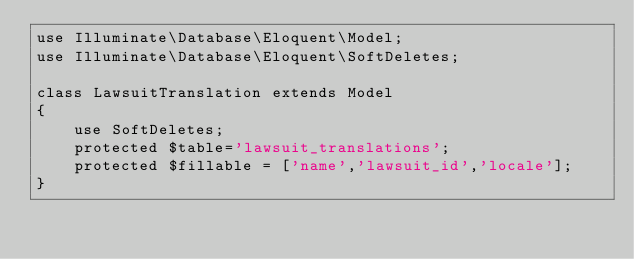Convert code to text. <code><loc_0><loc_0><loc_500><loc_500><_PHP_>use Illuminate\Database\Eloquent\Model;
use Illuminate\Database\Eloquent\SoftDeletes;

class LawsuitTranslation extends Model
{
    use SoftDeletes;
    protected $table='lawsuit_translations';
    protected $fillable = ['name','lawsuit_id','locale'];
}
</code> 